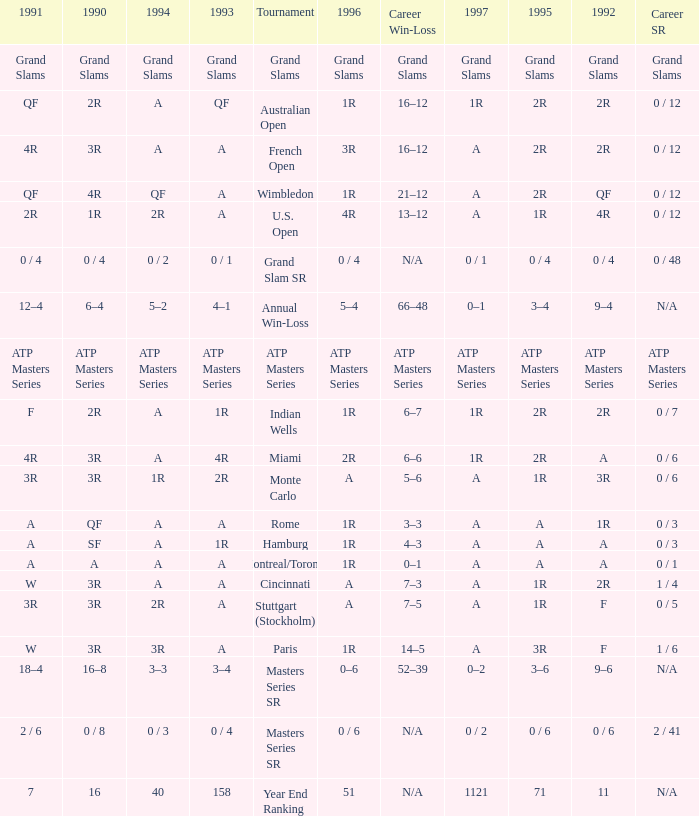What is 1997, when 1996 is "1R", when 1990 is "2R", and when 1991 is "F"? 1R. 